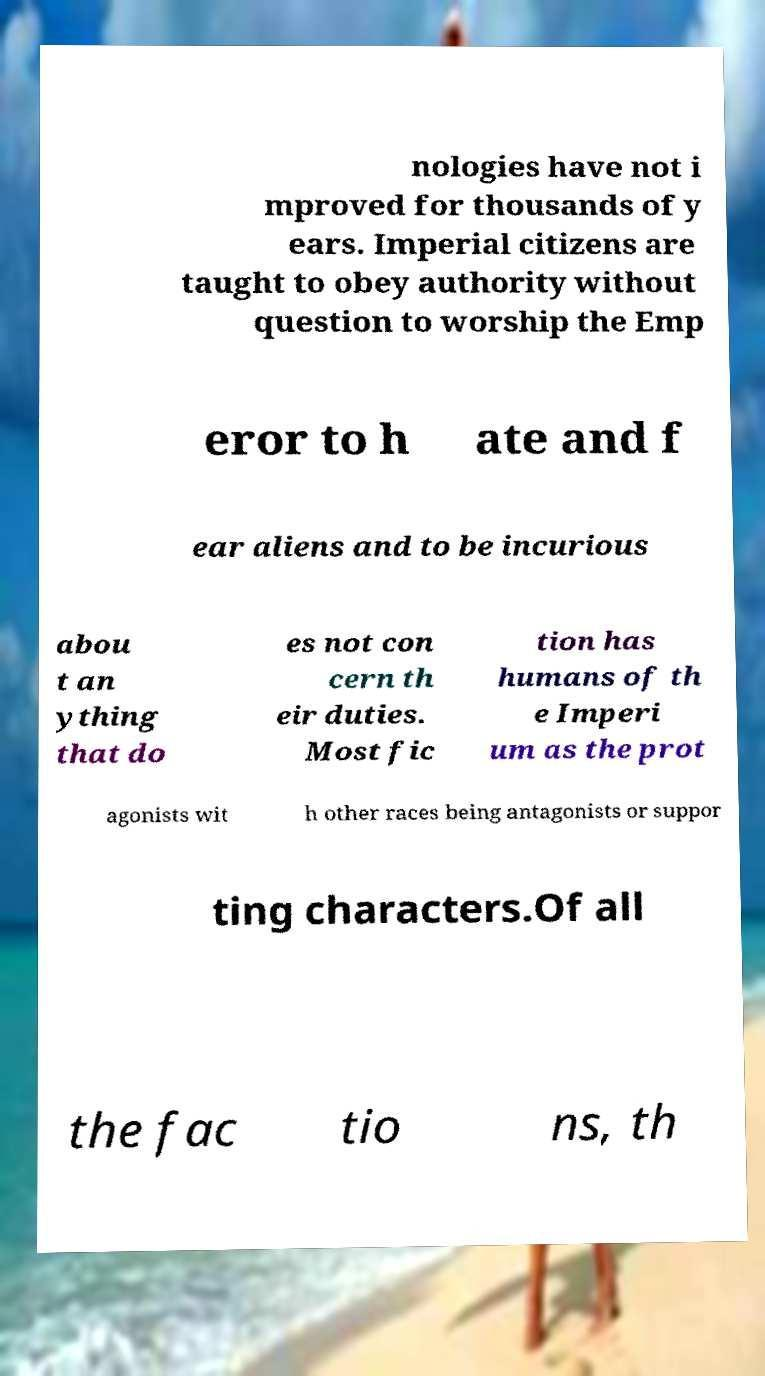Please read and relay the text visible in this image. What does it say? nologies have not i mproved for thousands of y ears. Imperial citizens are taught to obey authority without question to worship the Emp eror to h ate and f ear aliens and to be incurious abou t an ything that do es not con cern th eir duties. Most fic tion has humans of th e Imperi um as the prot agonists wit h other races being antagonists or suppor ting characters.Of all the fac tio ns, th 